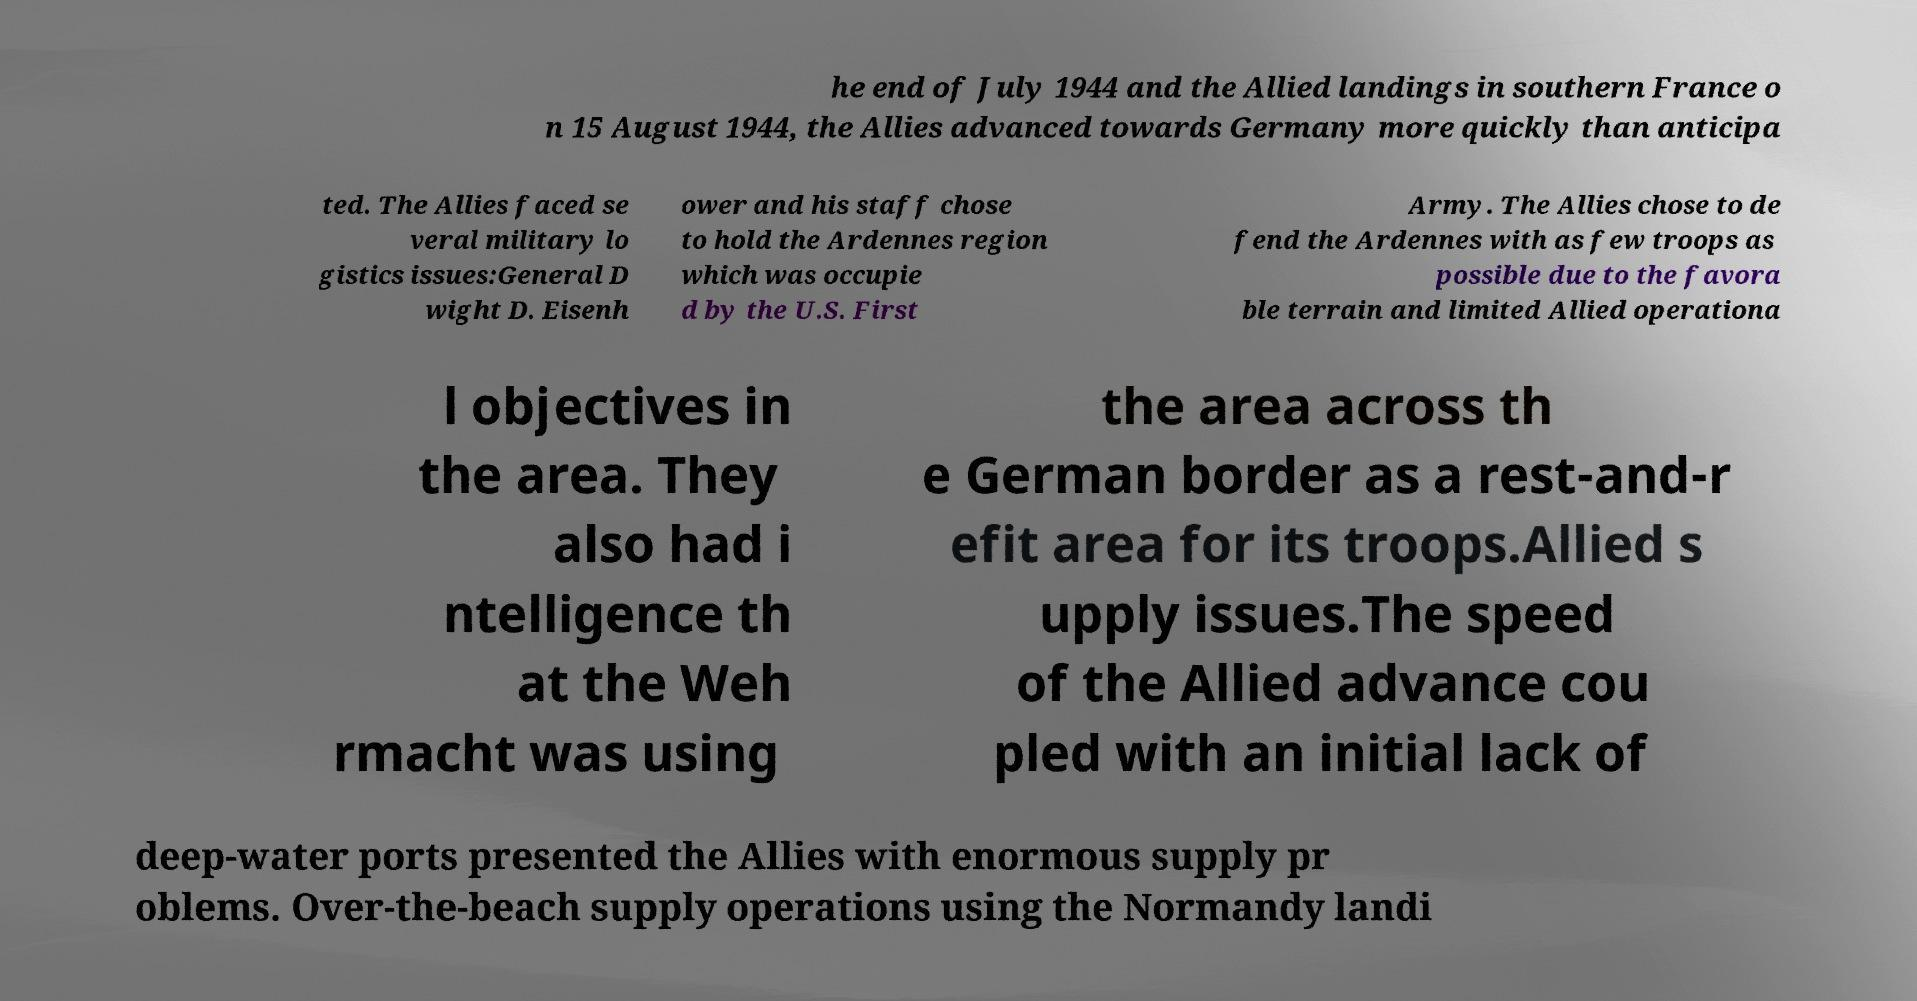For documentation purposes, I need the text within this image transcribed. Could you provide that? he end of July 1944 and the Allied landings in southern France o n 15 August 1944, the Allies advanced towards Germany more quickly than anticipa ted. The Allies faced se veral military lo gistics issues:General D wight D. Eisenh ower and his staff chose to hold the Ardennes region which was occupie d by the U.S. First Army. The Allies chose to de fend the Ardennes with as few troops as possible due to the favora ble terrain and limited Allied operationa l objectives in the area. They also had i ntelligence th at the Weh rmacht was using the area across th e German border as a rest-and-r efit area for its troops.Allied s upply issues.The speed of the Allied advance cou pled with an initial lack of deep-water ports presented the Allies with enormous supply pr oblems. Over-the-beach supply operations using the Normandy landi 